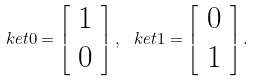<formula> <loc_0><loc_0><loc_500><loc_500>\ k e t { 0 } = \left [ \begin{array} { c } 1 \\ 0 \end{array} \right ] , \, \ k e t { 1 } = \left [ \begin{array} { c } 0 \\ 1 \end{array} \right ] .</formula> 